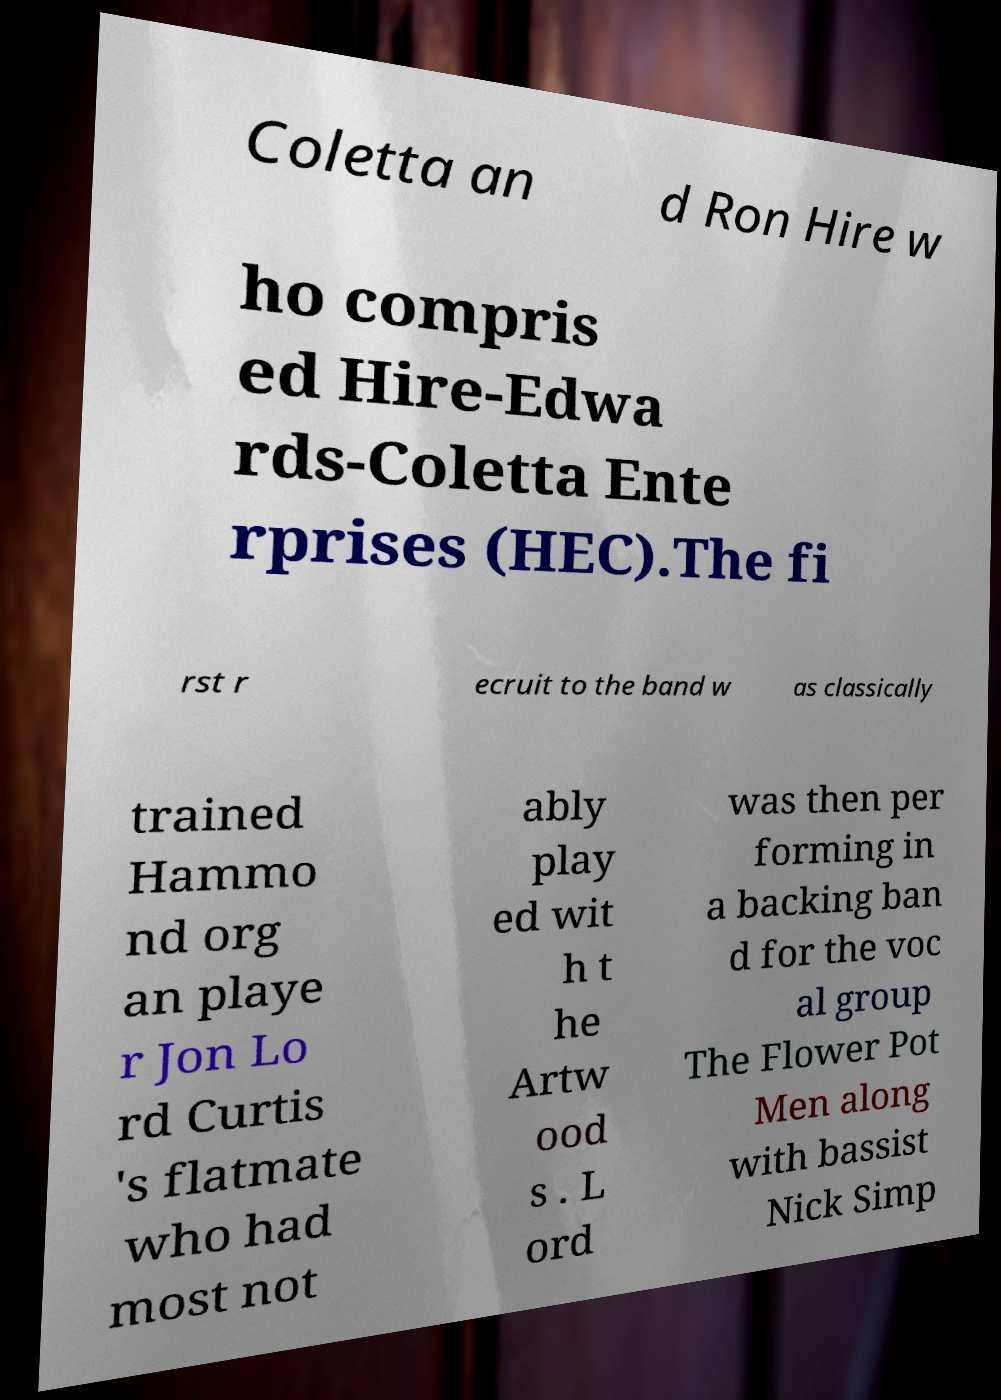Please identify and transcribe the text found in this image. Coletta an d Ron Hire w ho compris ed Hire-Edwa rds-Coletta Ente rprises (HEC).The fi rst r ecruit to the band w as classically trained Hammo nd org an playe r Jon Lo rd Curtis 's flatmate who had most not ably play ed wit h t he Artw ood s . L ord was then per forming in a backing ban d for the voc al group The Flower Pot Men along with bassist Nick Simp 